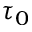<formula> <loc_0><loc_0><loc_500><loc_500>\tau _ { 0 }</formula> 